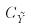<formula> <loc_0><loc_0><loc_500><loc_500>C _ { \tilde { Y } }</formula> 